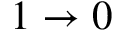<formula> <loc_0><loc_0><loc_500><loc_500>1 \rightarrow 0</formula> 